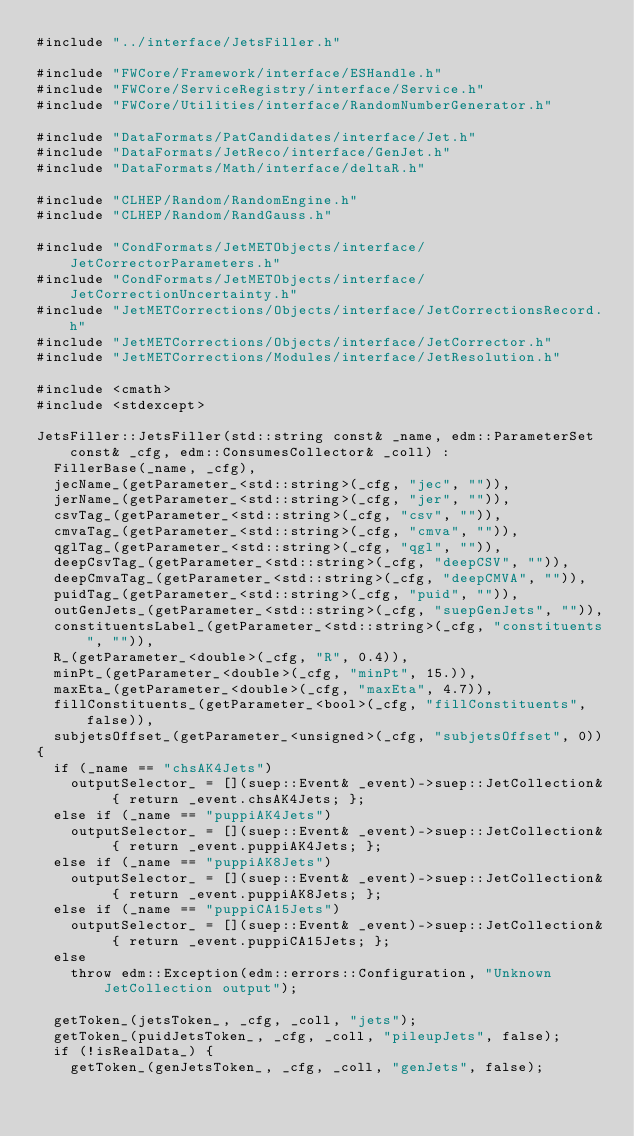<code> <loc_0><loc_0><loc_500><loc_500><_C++_>#include "../interface/JetsFiller.h"

#include "FWCore/Framework/interface/ESHandle.h"
#include "FWCore/ServiceRegistry/interface/Service.h"
#include "FWCore/Utilities/interface/RandomNumberGenerator.h"

#include "DataFormats/PatCandidates/interface/Jet.h"
#include "DataFormats/JetReco/interface/GenJet.h"
#include "DataFormats/Math/interface/deltaR.h"

#include "CLHEP/Random/RandomEngine.h"
#include "CLHEP/Random/RandGauss.h"

#include "CondFormats/JetMETObjects/interface/JetCorrectorParameters.h"
#include "CondFormats/JetMETObjects/interface/JetCorrectionUncertainty.h"
#include "JetMETCorrections/Objects/interface/JetCorrectionsRecord.h"
#include "JetMETCorrections/Objects/interface/JetCorrector.h"
#include "JetMETCorrections/Modules/interface/JetResolution.h"

#include <cmath>
#include <stdexcept>

JetsFiller::JetsFiller(std::string const& _name, edm::ParameterSet const& _cfg, edm::ConsumesCollector& _coll) :
  FillerBase(_name, _cfg),
  jecName_(getParameter_<std::string>(_cfg, "jec", "")),
  jerName_(getParameter_<std::string>(_cfg, "jer", "")),
  csvTag_(getParameter_<std::string>(_cfg, "csv", "")),
  cmvaTag_(getParameter_<std::string>(_cfg, "cmva", "")),
  qglTag_(getParameter_<std::string>(_cfg, "qgl", "")),
  deepCsvTag_(getParameter_<std::string>(_cfg, "deepCSV", "")),
  deepCmvaTag_(getParameter_<std::string>(_cfg, "deepCMVA", "")),
  puidTag_(getParameter_<std::string>(_cfg, "puid", "")),
  outGenJets_(getParameter_<std::string>(_cfg, "suepGenJets", "")),
  constituentsLabel_(getParameter_<std::string>(_cfg, "constituents", "")),
  R_(getParameter_<double>(_cfg, "R", 0.4)),
  minPt_(getParameter_<double>(_cfg, "minPt", 15.)),
  maxEta_(getParameter_<double>(_cfg, "maxEta", 4.7)),
  fillConstituents_(getParameter_<bool>(_cfg, "fillConstituents", false)),
  subjetsOffset_(getParameter_<unsigned>(_cfg, "subjetsOffset", 0))
{
  if (_name == "chsAK4Jets")
    outputSelector_ = [](suep::Event& _event)->suep::JetCollection& { return _event.chsAK4Jets; };
  else if (_name == "puppiAK4Jets")
    outputSelector_ = [](suep::Event& _event)->suep::JetCollection& { return _event.puppiAK4Jets; };
  else if (_name == "puppiAK8Jets")
    outputSelector_ = [](suep::Event& _event)->suep::JetCollection& { return _event.puppiAK8Jets; };
  else if (_name == "puppiCA15Jets")
    outputSelector_ = [](suep::Event& _event)->suep::JetCollection& { return _event.puppiCA15Jets; };
  else
    throw edm::Exception(edm::errors::Configuration, "Unknown JetCollection output");    

  getToken_(jetsToken_, _cfg, _coll, "jets");
  getToken_(puidJetsToken_, _cfg, _coll, "pileupJets", false);
  if (!isRealData_) {
    getToken_(genJetsToken_, _cfg, _coll, "genJets", false);</code> 